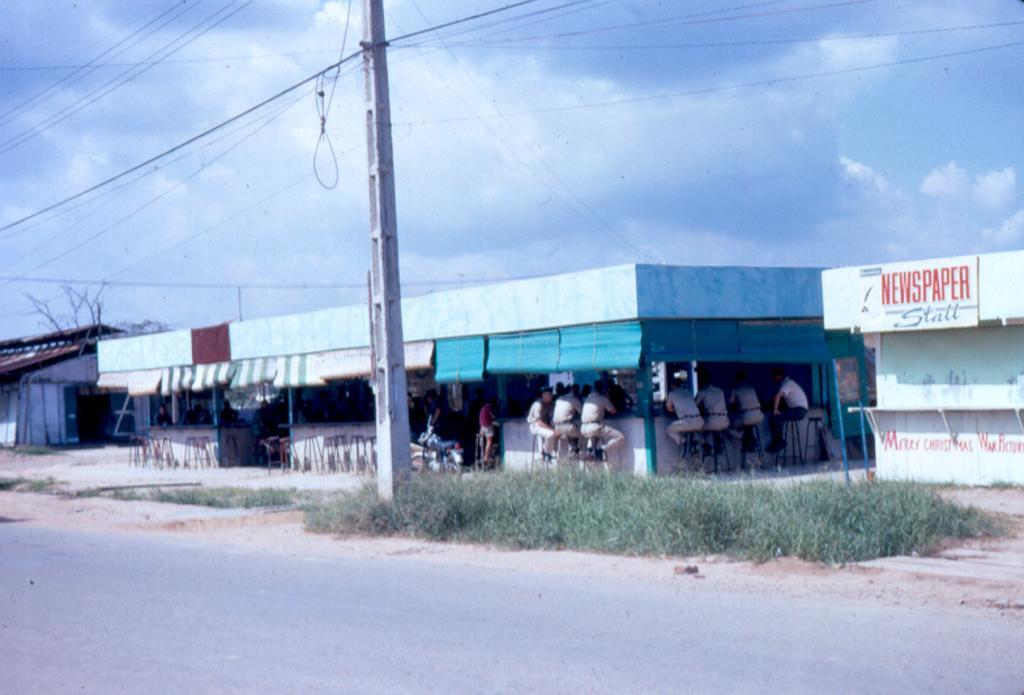In one or two sentences, can you explain what this image depicts? In the front of the image there are sheds, grass, people, stools, a house, board, pole, branches, road and objects. Under the open-shed we can see people are sitting on stools. Something is written on the board and wall. In the background of the image there is a cloudy sky.   